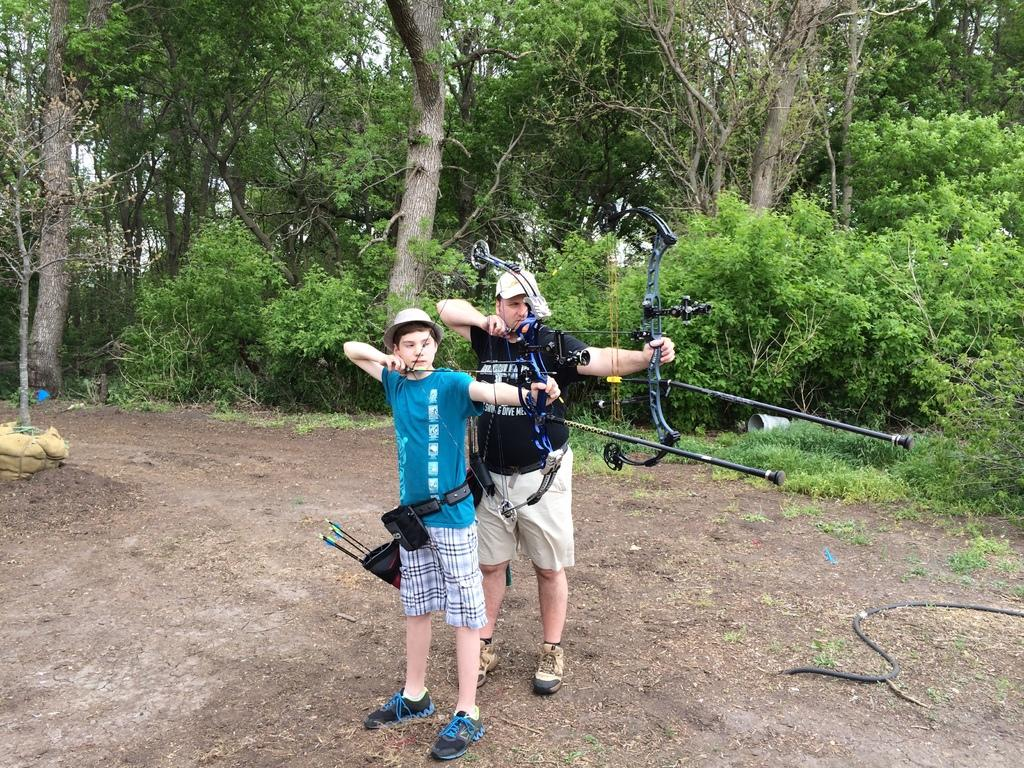How many people are in the image? There are two persons in the image. What are the persons doing in the image? The persons are standing and holding a bow and arrow. What might the persons be trying to do with the bow and arrow? The persons are trying to shoot at something. What can be seen in the background of the image? There are trees visible in the background of the image. What type of spark can be seen coming from the bow in the image? There is no spark visible in the image; the persons are simply holding the bow and arrow. Can you see any ducks in the image? There are no ducks present in the image. 